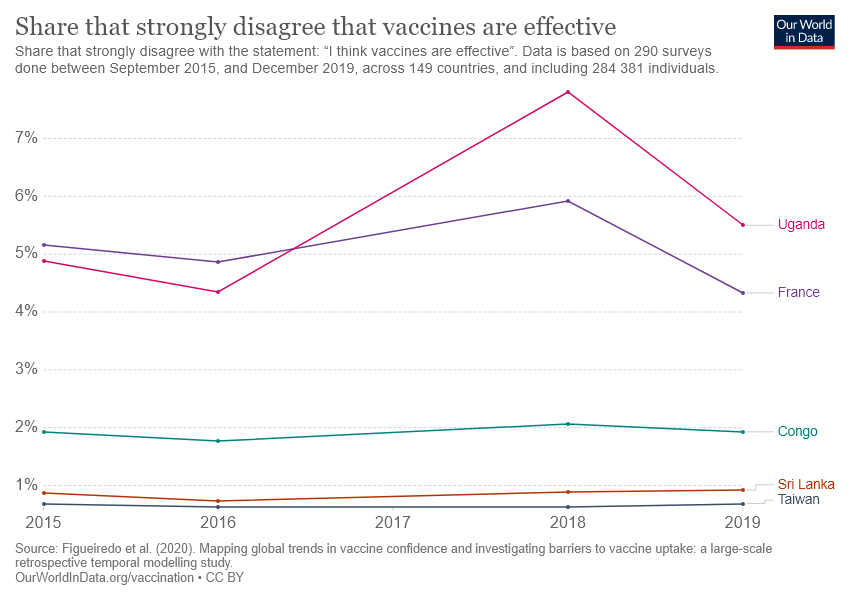Outline some significant characteristics in this image. According to estimates, France is approximately four and a half times larger than the Democratic Republic of the Congo. The chart shows data from a country that has crossed 7% in terms of the data shown. That country is Uganda. 